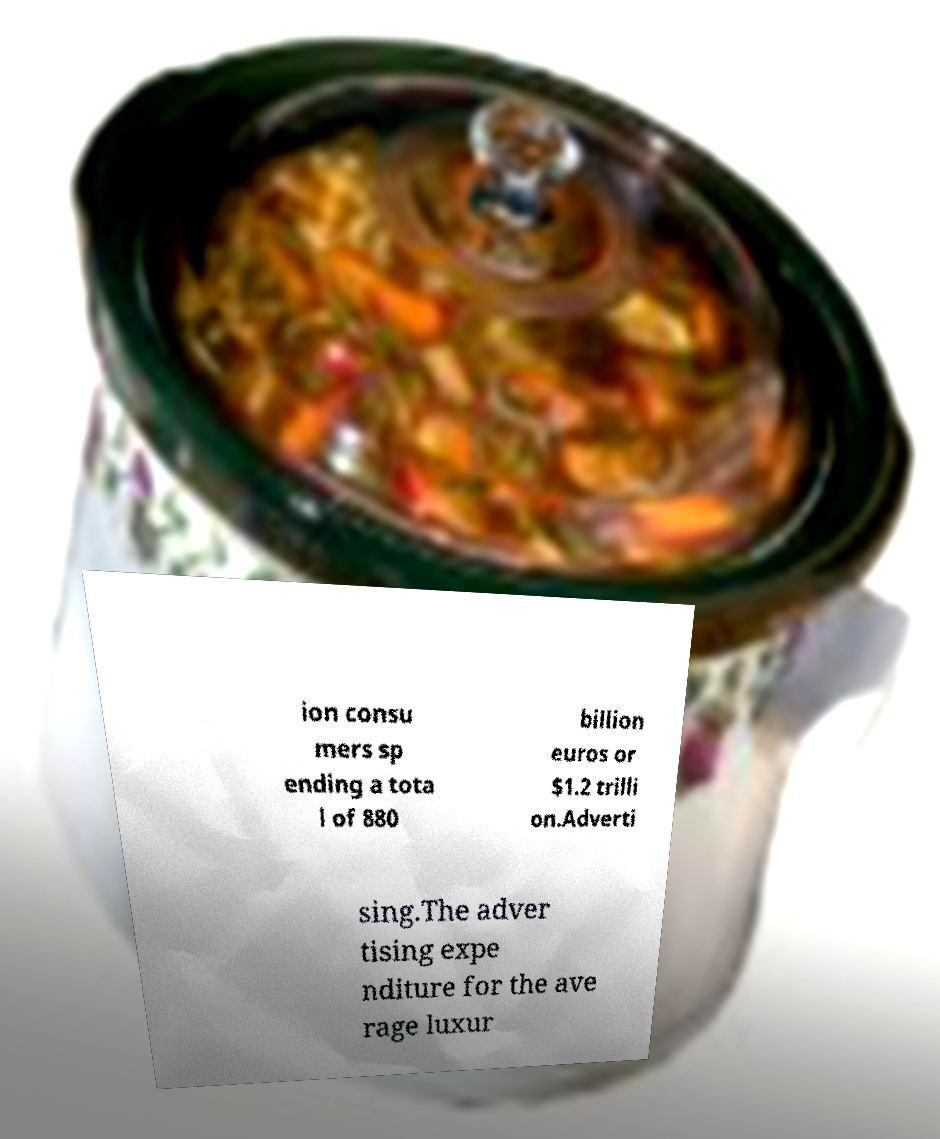Please read and relay the text visible in this image. What does it say? ion consu mers sp ending a tota l of 880 billion euros or $1.2 trilli on.Adverti sing.The adver tising expe nditure for the ave rage luxur 